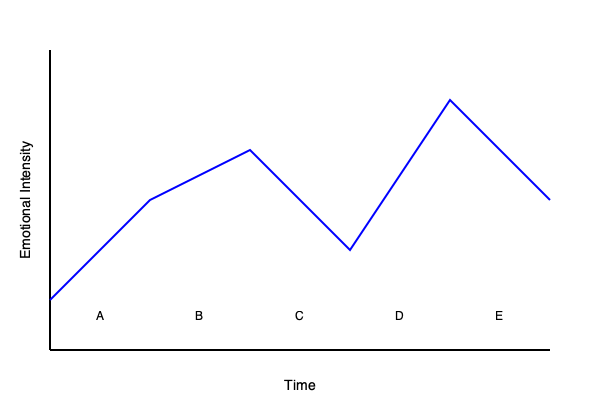Based on the relationship timeline graph, which stage is most likely to represent the "honeymoon phase" of a romantic relationship? To identify the "honeymoon phase" in a romantic relationship timeline, we need to consider the characteristics of this stage and match them to the graph:

1. The honeymoon phase typically occurs early in a relationship.
2. It is characterized by intense positive emotions and attraction.
3. This phase usually shows a rapid increase in emotional intensity.

Analyzing the graph:
1. Point A represents the start of the relationship.
2. The line between A and B shows a steep increase in emotional intensity.
3. The peak at point B indicates the highest level of emotional intensity early in the relationship.
4. After point B, the emotional intensity starts to decrease, which is typical as the honeymoon phase ends.

Therefore, the section of the graph between points A and B most likely represents the honeymoon phase of the romantic relationship. This phase shows the rapid increase in emotional intensity characteristic of the early stages of a romantic relationship.
Answer: B 